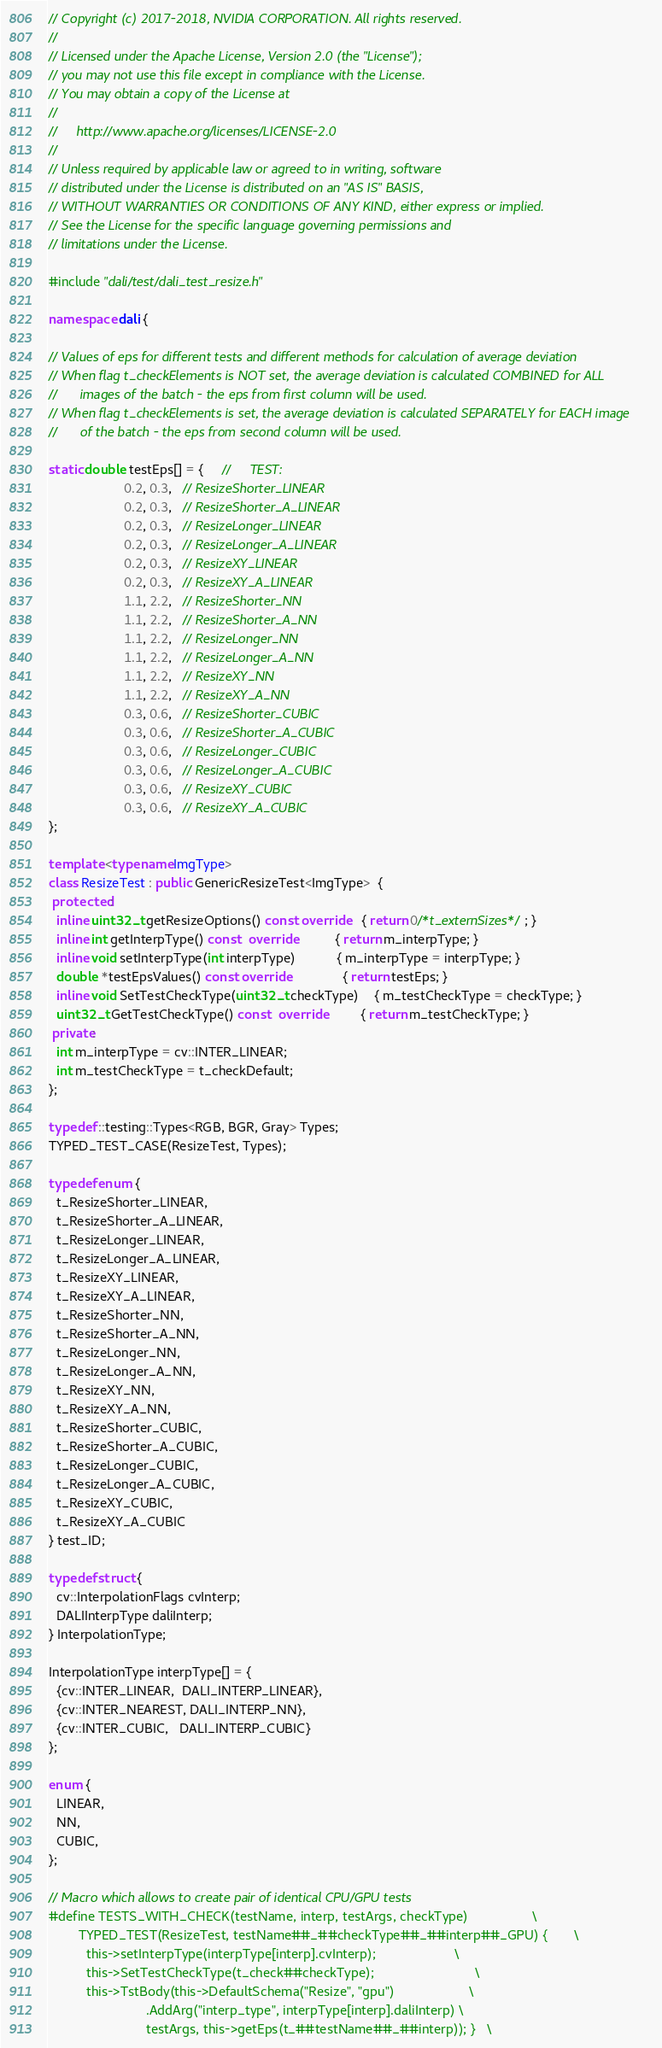<code> <loc_0><loc_0><loc_500><loc_500><_C++_>// Copyright (c) 2017-2018, NVIDIA CORPORATION. All rights reserved.
//
// Licensed under the Apache License, Version 2.0 (the "License");
// you may not use this file except in compliance with the License.
// You may obtain a copy of the License at
//
//     http://www.apache.org/licenses/LICENSE-2.0
//
// Unless required by applicable law or agreed to in writing, software
// distributed under the License is distributed on an "AS IS" BASIS,
// WITHOUT WARRANTIES OR CONDITIONS OF ANY KIND, either express or implied.
// See the License for the specific language governing permissions and
// limitations under the License.

#include "dali/test/dali_test_resize.h"

namespace dali {

// Values of eps for different tests and different methods for calculation of average deviation
// When flag t_checkElements is NOT set, the average deviation is calculated COMBINED for ALL
//      images of the batch - the eps from first column will be used.
// When flag t_checkElements is set, the average deviation is calculated SEPARATELY for EACH image
//      of the batch - the eps from second column will be used.

static double testEps[] = {     //     TEST:
                    0.2, 0.3,   // ResizeShorter_LINEAR
                    0.2, 0.3,   // ResizeShorter_A_LINEAR
                    0.2, 0.3,   // ResizeLonger_LINEAR
                    0.2, 0.3,   // ResizeLonger_A_LINEAR
                    0.2, 0.3,   // ResizeXY_LINEAR
                    0.2, 0.3,   // ResizeXY_A_LINEAR
                    1.1, 2.2,   // ResizeShorter_NN
                    1.1, 2.2,   // ResizeShorter_A_NN
                    1.1, 2.2,   // ResizeLonger_NN
                    1.1, 2.2,   // ResizeLonger_A_NN
                    1.1, 2.2,   // ResizeXY_NN
                    1.1, 2.2,   // ResizeXY_A_NN
                    0.3, 0.6,   // ResizeShorter_CUBIC
                    0.3, 0.6,   // ResizeShorter_A_CUBIC
                    0.3, 0.6,   // ResizeLonger_CUBIC
                    0.3, 0.6,   // ResizeLonger_A_CUBIC
                    0.3, 0.6,   // ResizeXY_CUBIC
                    0.3, 0.6,   // ResizeXY_A_CUBIC
};

template <typename ImgType>
class ResizeTest : public GenericResizeTest<ImgType>  {
 protected:
  inline uint32_t getResizeOptions() const override   { return 0/*t_externSizes*/; }
  inline int getInterpType() const  override          { return m_interpType; }
  inline void setInterpType(int interpType)           { m_interpType = interpType; }
  double *testEpsValues() const override              { return testEps; }
  inline void SetTestCheckType(uint32_t checkType)    { m_testCheckType = checkType; }
  uint32_t GetTestCheckType() const  override         { return m_testCheckType; }
 private:
  int m_interpType = cv::INTER_LINEAR;
  int m_testCheckType = t_checkDefault;
};

typedef ::testing::Types<RGB, BGR, Gray> Types;
TYPED_TEST_CASE(ResizeTest, Types);

typedef enum {
  t_ResizeShorter_LINEAR,
  t_ResizeShorter_A_LINEAR,
  t_ResizeLonger_LINEAR,
  t_ResizeLonger_A_LINEAR,
  t_ResizeXY_LINEAR,
  t_ResizeXY_A_LINEAR,
  t_ResizeShorter_NN,
  t_ResizeShorter_A_NN,
  t_ResizeLonger_NN,
  t_ResizeLonger_A_NN,
  t_ResizeXY_NN,
  t_ResizeXY_A_NN,
  t_ResizeShorter_CUBIC,
  t_ResizeShorter_A_CUBIC,
  t_ResizeLonger_CUBIC,
  t_ResizeLonger_A_CUBIC,
  t_ResizeXY_CUBIC,
  t_ResizeXY_A_CUBIC
} test_ID;

typedef struct {
  cv::InterpolationFlags cvInterp;
  DALIInterpType daliInterp;
} InterpolationType;

InterpolationType interpType[] = {
  {cv::INTER_LINEAR,  DALI_INTERP_LINEAR},
  {cv::INTER_NEAREST, DALI_INTERP_NN},
  {cv::INTER_CUBIC,   DALI_INTERP_CUBIC}
};

enum {
  LINEAR,
  NN,
  CUBIC,
};

// Macro which allows to create pair of identical CPU/GPU tests
#define TESTS_WITH_CHECK(testName, interp, testArgs, checkType)                 \
        TYPED_TEST(ResizeTest, testName##_##checkType##_##interp##_GPU) {       \
          this->setInterpType(interpType[interp].cvInterp);                     \
          this->SetTestCheckType(t_check##checkType);                           \
          this->TstBody(this->DefaultSchema("Resize", "gpu")                    \
                          .AddArg("interp_type", interpType[interp].daliInterp) \
                          testArgs, this->getEps(t_##testName##_##interp)); }   \</code> 